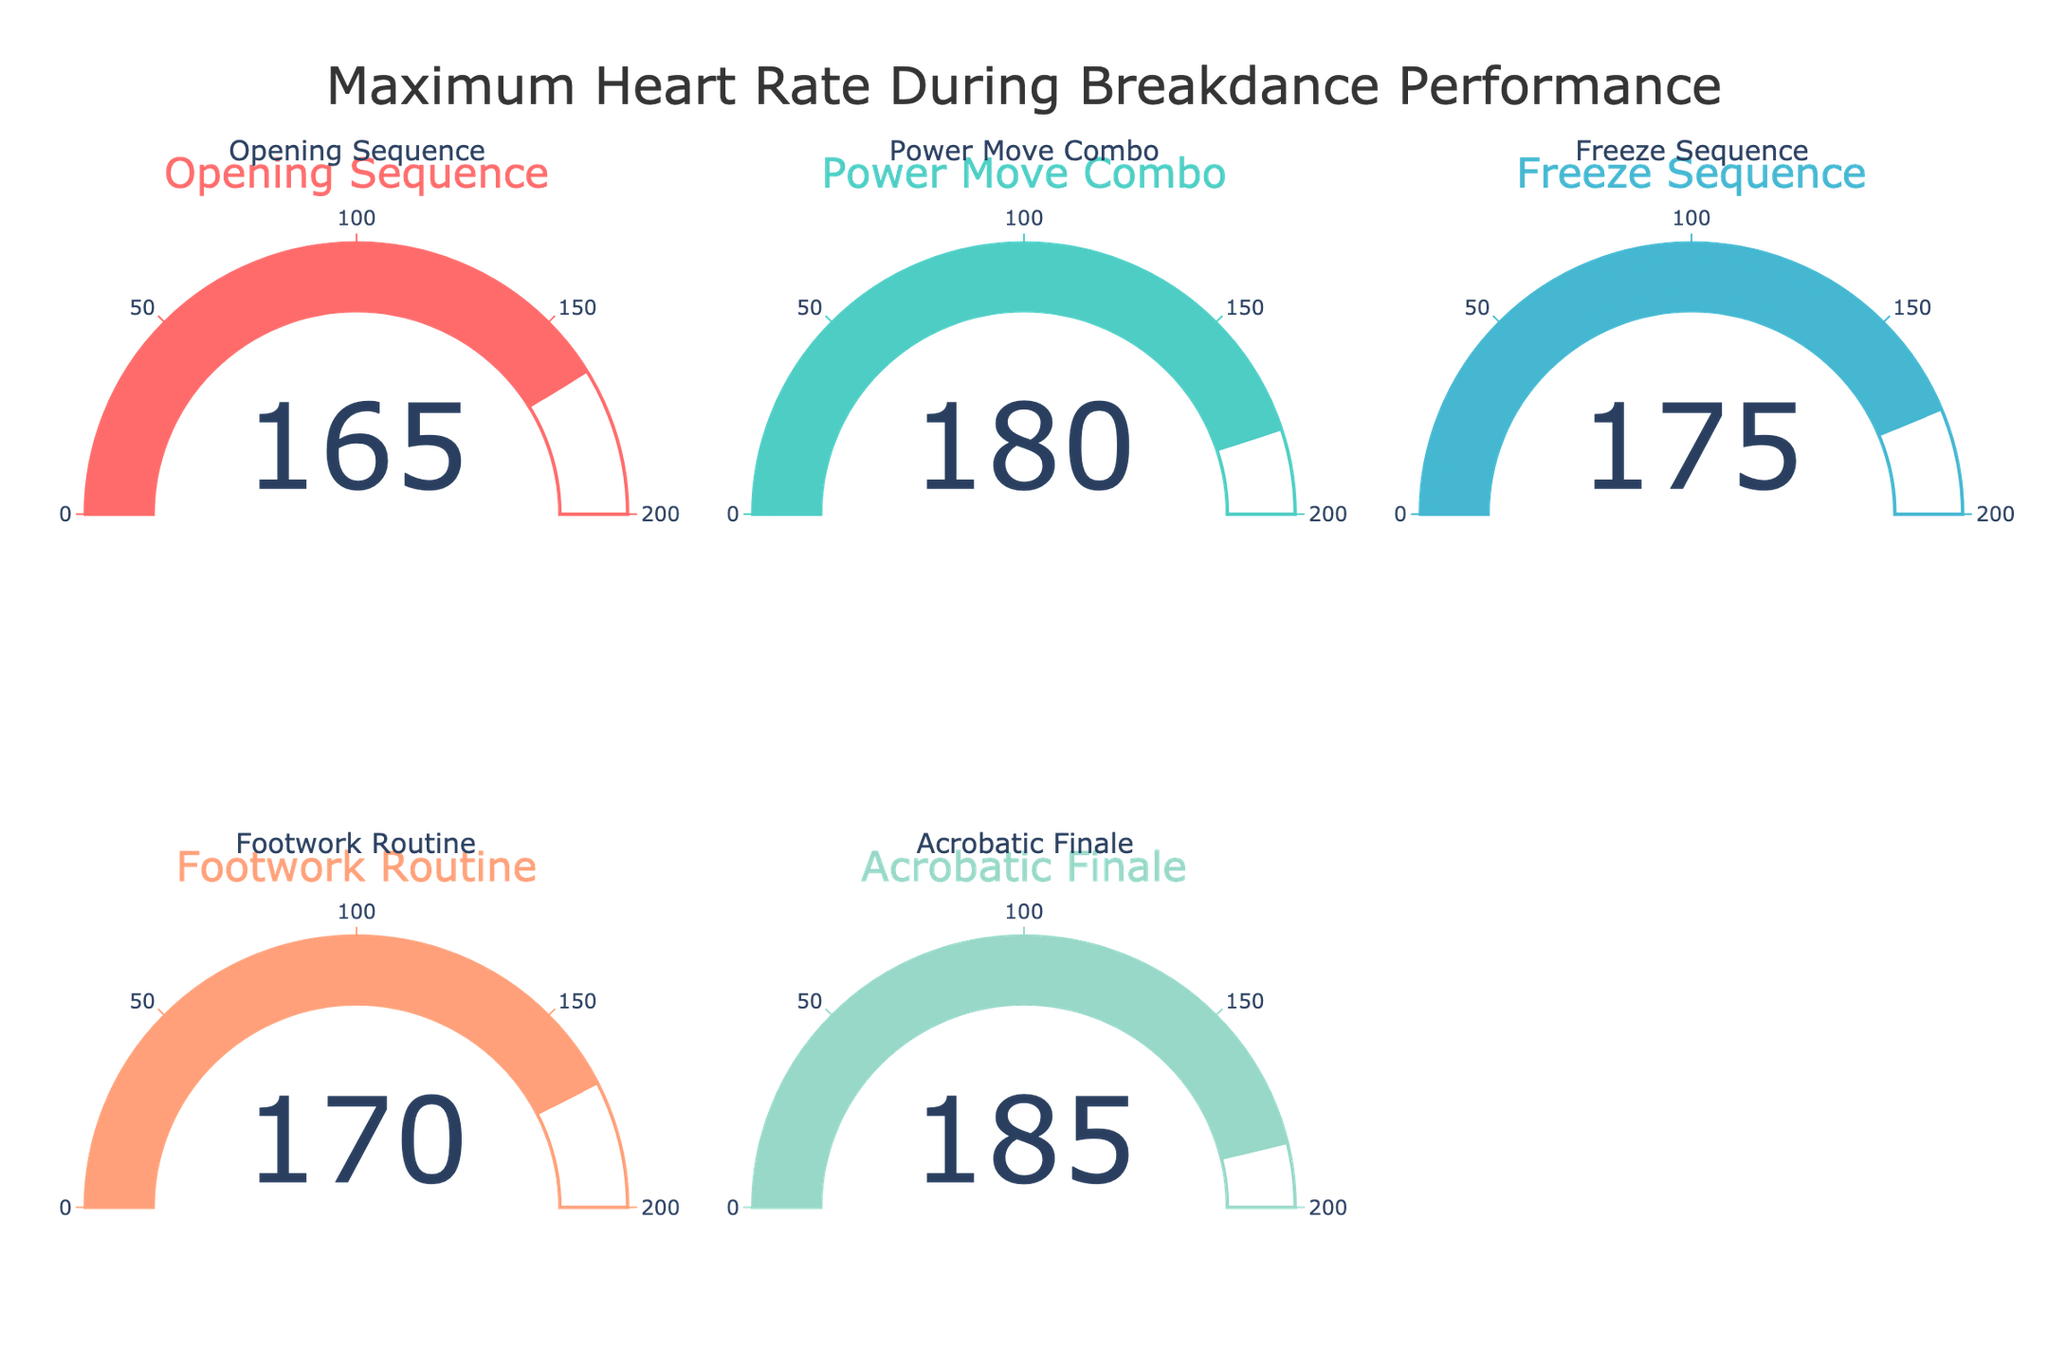What is the maximum heart rate during the Power Move Combo? The gauge chart for the 'Power Move Combo' shows a heart rate of 180.
Answer: 180 Which performance showed the highest maximum heart rate? The gauge for the 'Acrobatic Finale' shows the highest heart rate at 185.
Answer: Acrobatic Finale What is the title of the figure? The title is displayed at the top center of the figure: "Maximum Heart Rate During Breakdance Performance".
Answer: Maximum Heart Rate During Breakdance Performance What is the difference in maximum heart rate between the Footwork Routine and Opening Sequence? The heart rate for Footwork Routine is 170 and for Opening Sequence is 165, so the difference is 170 - 165 = 5.
Answer: 5 How many data points are displayed in the gauge chart? There are five performances listed, each represented by a gauge: Opening Sequence, Power Move Combo, Freeze Sequence, Footwork Routine, Acrobatic Finale.
Answer: 5 Which performance has the lowest maximum heart rate? The gauge for the 'Opening Sequence' shows the lowest heart rate at 165.
Answer: Opening Sequence What is the average maximum heart rate across all performances? Summing the heart rates (165 + 180 + 175 + 170 + 185) = 875, and dividing by the number of performances (5) gives an average of 875/5 = 175.
Answer: 175 Is the maximum heart rate during the Acrobatic Finale greater than 180? The gauge chart for the 'Acrobatic Finale' displays a heart rate of 185, which is greater than 180.
Answer: Yes Which performance has a higher maximum heart rate: Freeze Sequence or Footwork Routine? The gauge for Freeze Sequence shows 175, and the gauge for Footwork Routine shows 170. Thus, the Freeze Sequence has a higher rate.
Answer: Freeze Sequence 